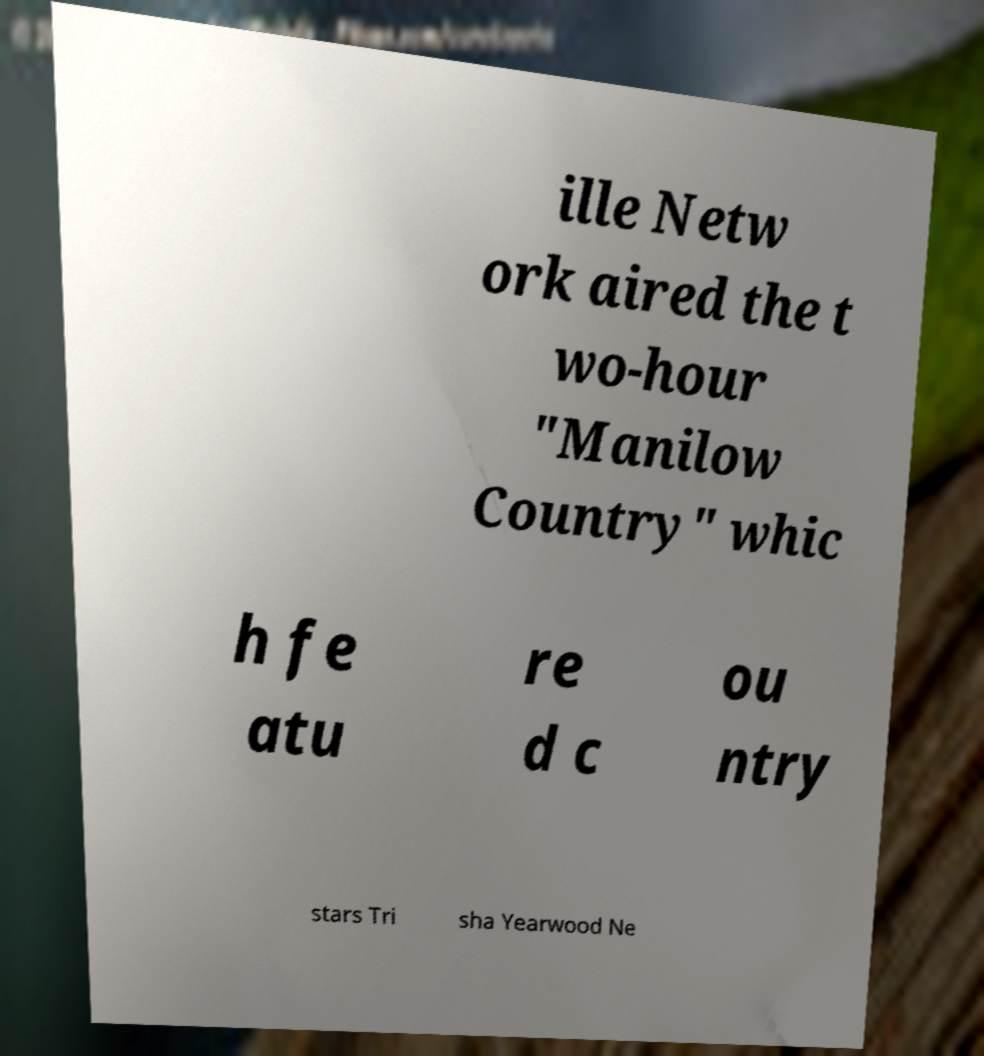Can you read and provide the text displayed in the image?This photo seems to have some interesting text. Can you extract and type it out for me? ille Netw ork aired the t wo-hour "Manilow Country" whic h fe atu re d c ou ntry stars Tri sha Yearwood Ne 